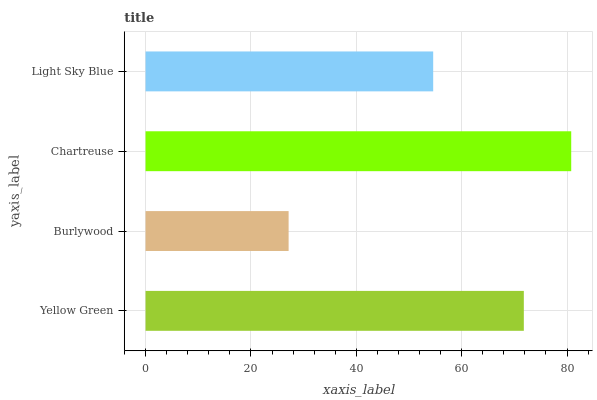Is Burlywood the minimum?
Answer yes or no. Yes. Is Chartreuse the maximum?
Answer yes or no. Yes. Is Chartreuse the minimum?
Answer yes or no. No. Is Burlywood the maximum?
Answer yes or no. No. Is Chartreuse greater than Burlywood?
Answer yes or no. Yes. Is Burlywood less than Chartreuse?
Answer yes or no. Yes. Is Burlywood greater than Chartreuse?
Answer yes or no. No. Is Chartreuse less than Burlywood?
Answer yes or no. No. Is Yellow Green the high median?
Answer yes or no. Yes. Is Light Sky Blue the low median?
Answer yes or no. Yes. Is Chartreuse the high median?
Answer yes or no. No. Is Yellow Green the low median?
Answer yes or no. No. 